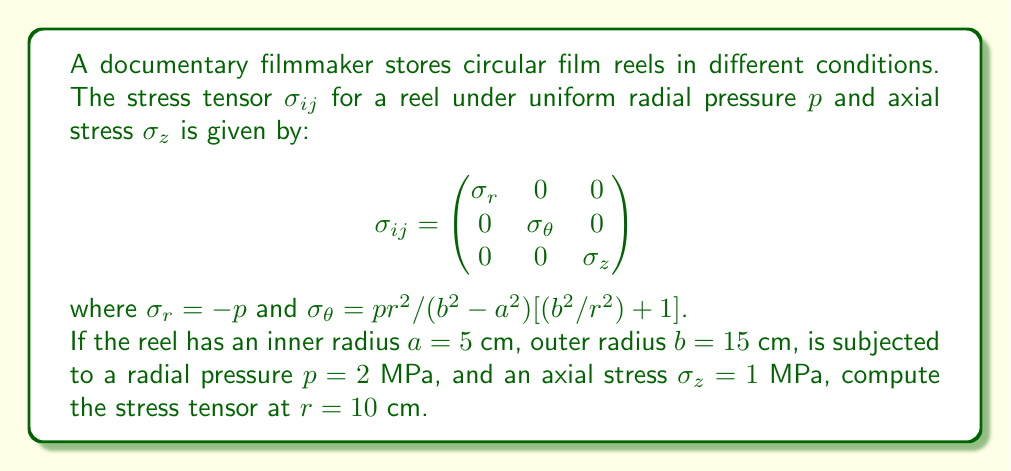Provide a solution to this math problem. Let's approach this step-by-step:

1) We're given the general form of the stress tensor:

   $$\sigma_{ij} = \begin{pmatrix}
   \sigma_r & 0 & 0 \\
   0 & \sigma_\theta & 0 \\
   0 & 0 & \sigma_z
   \end{pmatrix}$$

2) We know that $\sigma_r = -p = -2$ MPa

3) For $\sigma_\theta$, we use the formula:
   
   $\sigma_\theta = \frac{pr^2}{b^2-a^2}[(b^2/r^2)+1]$

4) Let's calculate the components:
   
   $b^2-a^2 = 15^2 - 5^2 = 200$ cm²
   
   At $r=10$ cm: $b^2/r^2 = 15^2/10^2 = 2.25$

5) Substituting into the $\sigma_\theta$ formula:

   $\sigma_\theta = \frac{2 \cdot 10^2}{200}[2.25+1] = 3.25$ MPa

6) We're given $\sigma_z = 1$ MPa

7) Now we can fill in the stress tensor:

   $$\sigma_{ij} = \begin{pmatrix}
   -2 & 0 & 0 \\
   0 & 3.25 & 0 \\
   0 & 0 & 1
   \end{pmatrix}$$ MPa
Answer: $$\sigma_{ij} = \begin{pmatrix}
-2 & 0 & 0 \\
0 & 3.25 & 0 \\
0 & 0 & 1
\end{pmatrix}$$ MPa 